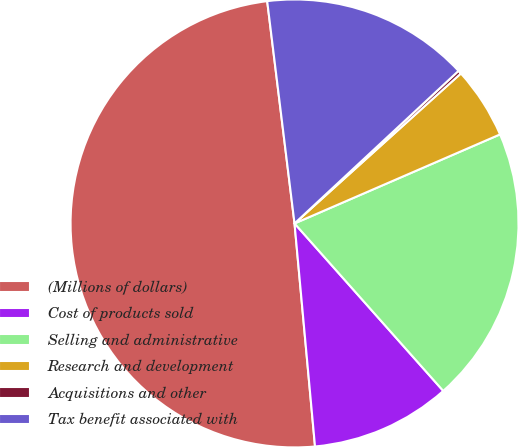Convert chart. <chart><loc_0><loc_0><loc_500><loc_500><pie_chart><fcel>(Millions of dollars)<fcel>Cost of products sold<fcel>Selling and administrative<fcel>Research and development<fcel>Acquisitions and other<fcel>Tax benefit associated with<nl><fcel>49.51%<fcel>10.1%<fcel>19.95%<fcel>5.17%<fcel>0.25%<fcel>15.02%<nl></chart> 